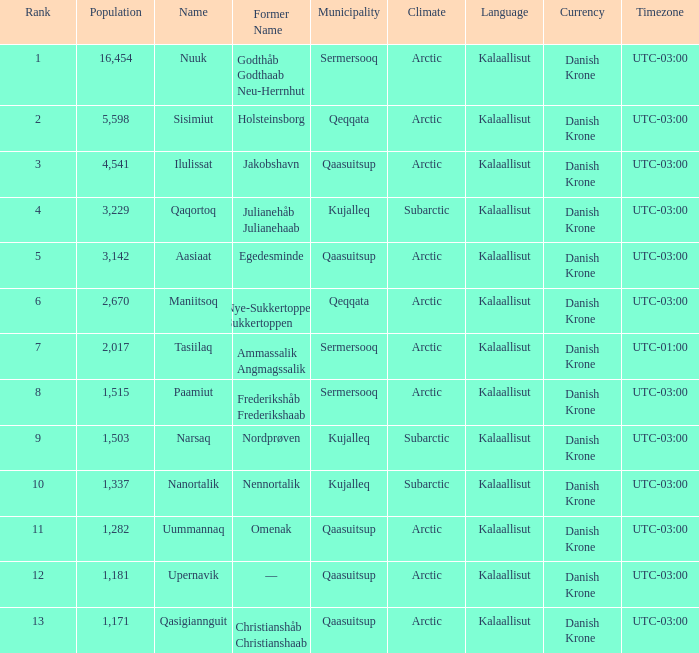Who has a former name of nordprøven? Narsaq. 